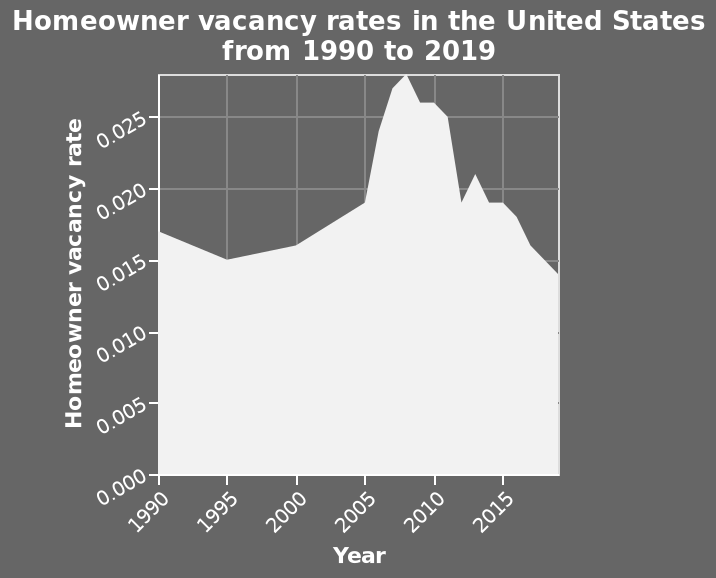<image>
Offer a thorough analysis of the image. Homeowner vavancy rates recorded peaked between 2005 and 2010. The lowest vacancy rate is recorded after 2015 with vacancy rates falling to the end of the recorded periodThe falling trend of vacancies seems to spike upwards again shortly after 2010. In which year was the homeowner vacancy rate the lowest?  The homeowner vacancy rate was the lowest in 2020. What is measured on the y-axis of the graph? The y-axis measures the homeowner vacancy rate ranging from 0.000 to 0.025. When was the homeowner vacancy rate highest?  The homeowner vacancy rate was highest between 2005 and 2010. 